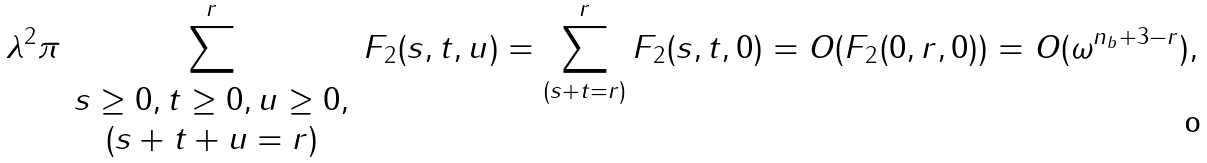<formula> <loc_0><loc_0><loc_500><loc_500>\lambda ^ { 2 } \pi \sum _ { \begin{array} { c } s \geq 0 , t \geq 0 , u \geq 0 , \\ ( s + t + u = r ) \end{array} } ^ { r } F _ { 2 } ( s , t , u ) = \sum _ { ( s + t = r ) } ^ { r } F _ { 2 } ( s , t , 0 ) = O ( F _ { 2 } ( 0 , r , 0 ) ) = O ( \omega ^ { n _ { b } + 3 - r } ) ,</formula> 